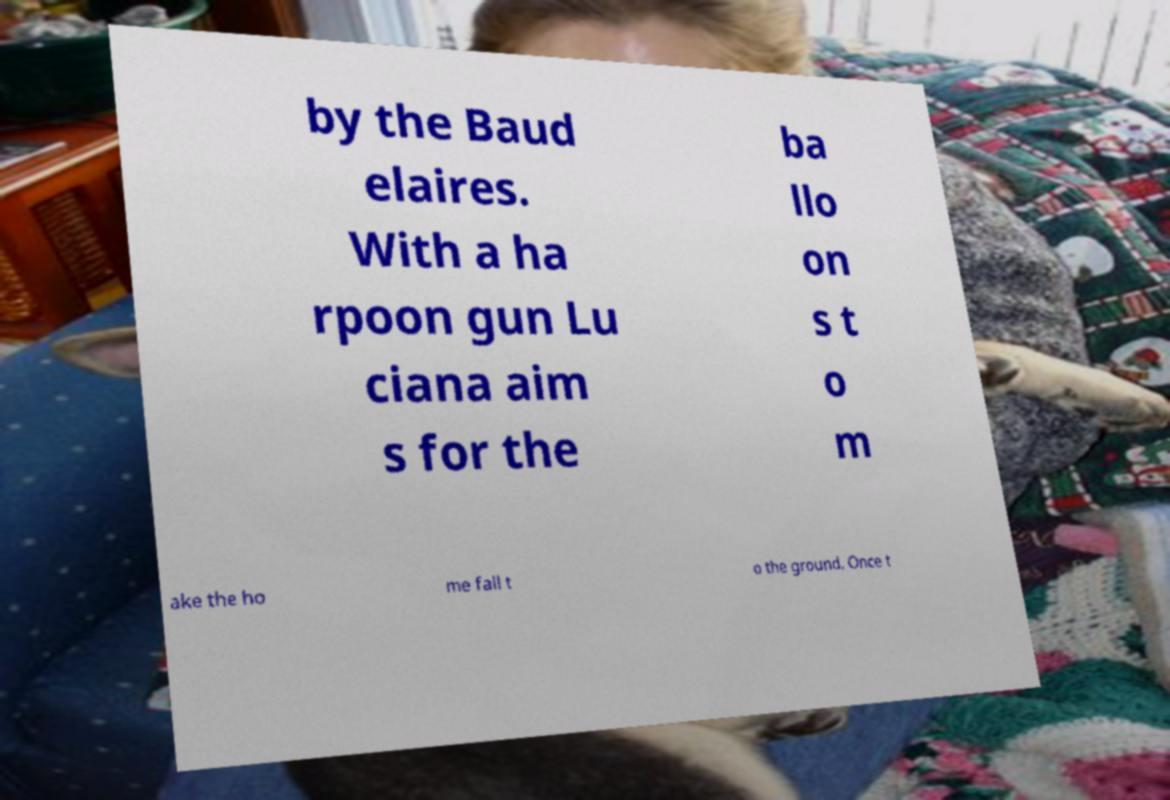There's text embedded in this image that I need extracted. Can you transcribe it verbatim? by the Baud elaires. With a ha rpoon gun Lu ciana aim s for the ba llo on s t o m ake the ho me fall t o the ground. Once t 